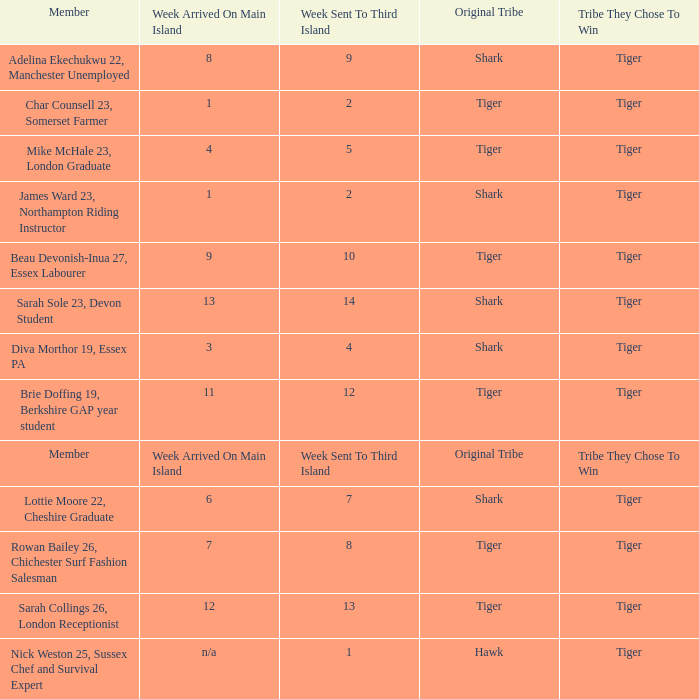Could you parse the entire table? {'header': ['Member', 'Week Arrived On Main Island', 'Week Sent To Third Island', 'Original Tribe', 'Tribe They Chose To Win'], 'rows': [['Adelina Ekechukwu 22, Manchester Unemployed', '8', '9', 'Shark', 'Tiger'], ['Char Counsell 23, Somerset Farmer', '1', '2', 'Tiger', 'Tiger'], ['Mike McHale 23, London Graduate', '4', '5', 'Tiger', 'Tiger'], ['James Ward 23, Northampton Riding Instructor', '1', '2', 'Shark', 'Tiger'], ['Beau Devonish-Inua 27, Essex Labourer', '9', '10', 'Tiger', 'Tiger'], ['Sarah Sole 23, Devon Student', '13', '14', 'Shark', 'Tiger'], ['Diva Morthor 19, Essex PA', '3', '4', 'Shark', 'Tiger'], ['Brie Doffing 19, Berkshire GAP year student', '11', '12', 'Tiger', 'Tiger'], ['Member', 'Week Arrived On Main Island', 'Week Sent To Third Island', 'Original Tribe', 'Tribe They Chose To Win'], ['Lottie Moore 22, Cheshire Graduate', '6', '7', 'Shark', 'Tiger'], ['Rowan Bailey 26, Chichester Surf Fashion Salesman', '7', '8', 'Tiger', 'Tiger'], ['Sarah Collings 26, London Receptionist', '12', '13', 'Tiger', 'Tiger'], ['Nick Weston 25, Sussex Chef and Survival Expert', 'n/a', '1', 'Hawk', 'Tiger']]} What week was the member who arrived on the main island in week 6 sent to the third island? 7.0. 